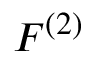Convert formula to latex. <formula><loc_0><loc_0><loc_500><loc_500>F ^ { ( 2 ) }</formula> 